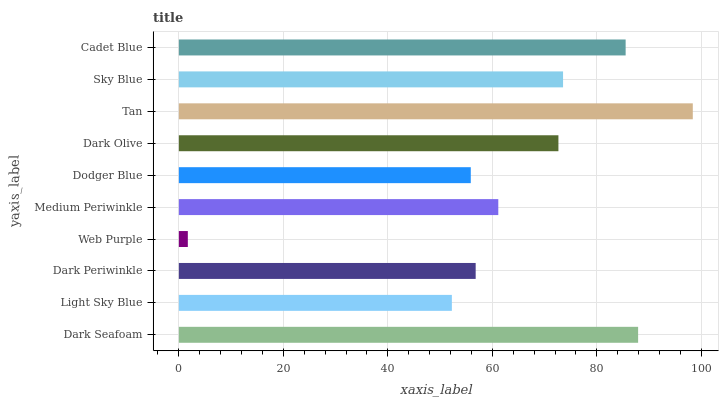Is Web Purple the minimum?
Answer yes or no. Yes. Is Tan the maximum?
Answer yes or no. Yes. Is Light Sky Blue the minimum?
Answer yes or no. No. Is Light Sky Blue the maximum?
Answer yes or no. No. Is Dark Seafoam greater than Light Sky Blue?
Answer yes or no. Yes. Is Light Sky Blue less than Dark Seafoam?
Answer yes or no. Yes. Is Light Sky Blue greater than Dark Seafoam?
Answer yes or no. No. Is Dark Seafoam less than Light Sky Blue?
Answer yes or no. No. Is Dark Olive the high median?
Answer yes or no. Yes. Is Medium Periwinkle the low median?
Answer yes or no. Yes. Is Sky Blue the high median?
Answer yes or no. No. Is Dark Seafoam the low median?
Answer yes or no. No. 